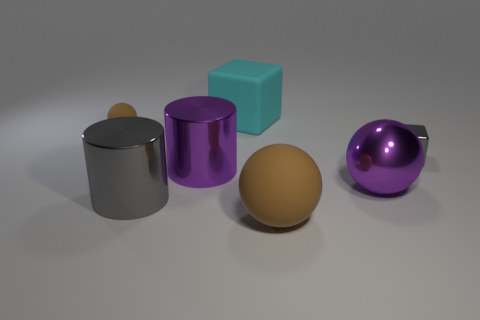What is the material of the other object that is the same shape as the tiny gray object?
Keep it short and to the point. Rubber. There is a small shiny thing that is the same shape as the big cyan thing; what color is it?
Provide a short and direct response. Gray. There is a small thing that is to the right of the large gray metallic thing; is it the same color as the ball to the left of the large rubber block?
Make the answer very short. No. Is the number of big purple things that are behind the tiny brown ball less than the number of balls that are on the left side of the big purple cylinder?
Your answer should be compact. Yes. There is a brown rubber thing that is right of the tiny rubber thing; what shape is it?
Ensure brevity in your answer.  Sphere. There is another ball that is the same color as the tiny ball; what material is it?
Offer a terse response. Rubber. How many other objects are the same material as the large purple cylinder?
Provide a short and direct response. 3. There is a tiny gray metallic thing; is its shape the same as the gray thing in front of the purple metallic cylinder?
Your answer should be very brief. No. The large cyan thing that is made of the same material as the tiny brown object is what shape?
Keep it short and to the point. Cube. Are there more brown balls that are behind the tiny gray shiny object than big things that are behind the tiny matte object?
Provide a succinct answer. No. 